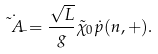<formula> <loc_0><loc_0><loc_500><loc_500>\dot { \tilde { A } _ { - } } = \frac { \sqrt { L } } { g } \tilde { \chi } _ { 0 } \dot { p } ( n , + ) .</formula> 